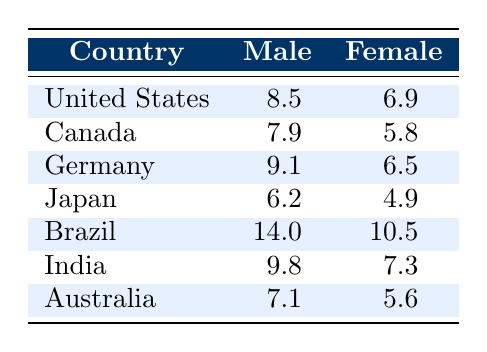What is the mortality rate for males in the United States? The table shows a specific row for the United States under the Male column with a value of 8.5 for the mortality rate.
Answer: 8.5 What is the mortality rate for females in Canada? In the table, the row for Canada under the Female column indicates a mortality rate of 5.8.
Answer: 5.8 Which country has the highest mortality rate for females? By comparing the Female mortality rates across all countries, Brazil has the highest rate at 10.5.
Answer: Brazil What is the difference in mortality rates between males and females in Japan? The mortality rate for males in Japan is 6.2 and for females is 4.9. The difference can be calculated as 6.2 - 4.9 = 1.3.
Answer: 1.3 Is the mortality rate for males in Australia higher than that in Canada? The mortality rate for males in Australia is 7.1, while in Canada it is 7.9. Since 7.1 is less than 7.9, the statement is false.
Answer: No What is the average mortality rate for males across all countries listed? Adding the male mortality rates: 8.5 (US) + 7.9 (Canada) + 9.1 (Germany) + 6.2 (Japan) + 14.0 (Brazil) + 9.8 (India) + 7.1 (Australia) gives a total of 62.6. Dividing by 7 (the number of countries) gives an average of 8.94.
Answer: 8.94 Which gender has a lower mortality rate in Germany? The table shows that males in Germany have a mortality rate of 9.1, while females have a rate of 6.5. Since 6.5 is less than 9.1, females have a lower mortality rate.
Answer: Females How many countries have a mortality rate for males greater than 8? By inspecting the Male column, the countries with rates greater than 8 are the United States (8.5), Germany (9.1), Brazil (14.0), and India (9.8). This sums to a total of 4 countries.
Answer: 4 What is the ratio of male to female mortality rates in Brazil? The male mortality rate in Brazil is 14.0, and the female rate is 10.5. The ratio can be calculated as 14.0 / 10.5, which simplifies to approximately 1.33.
Answer: 1.33 